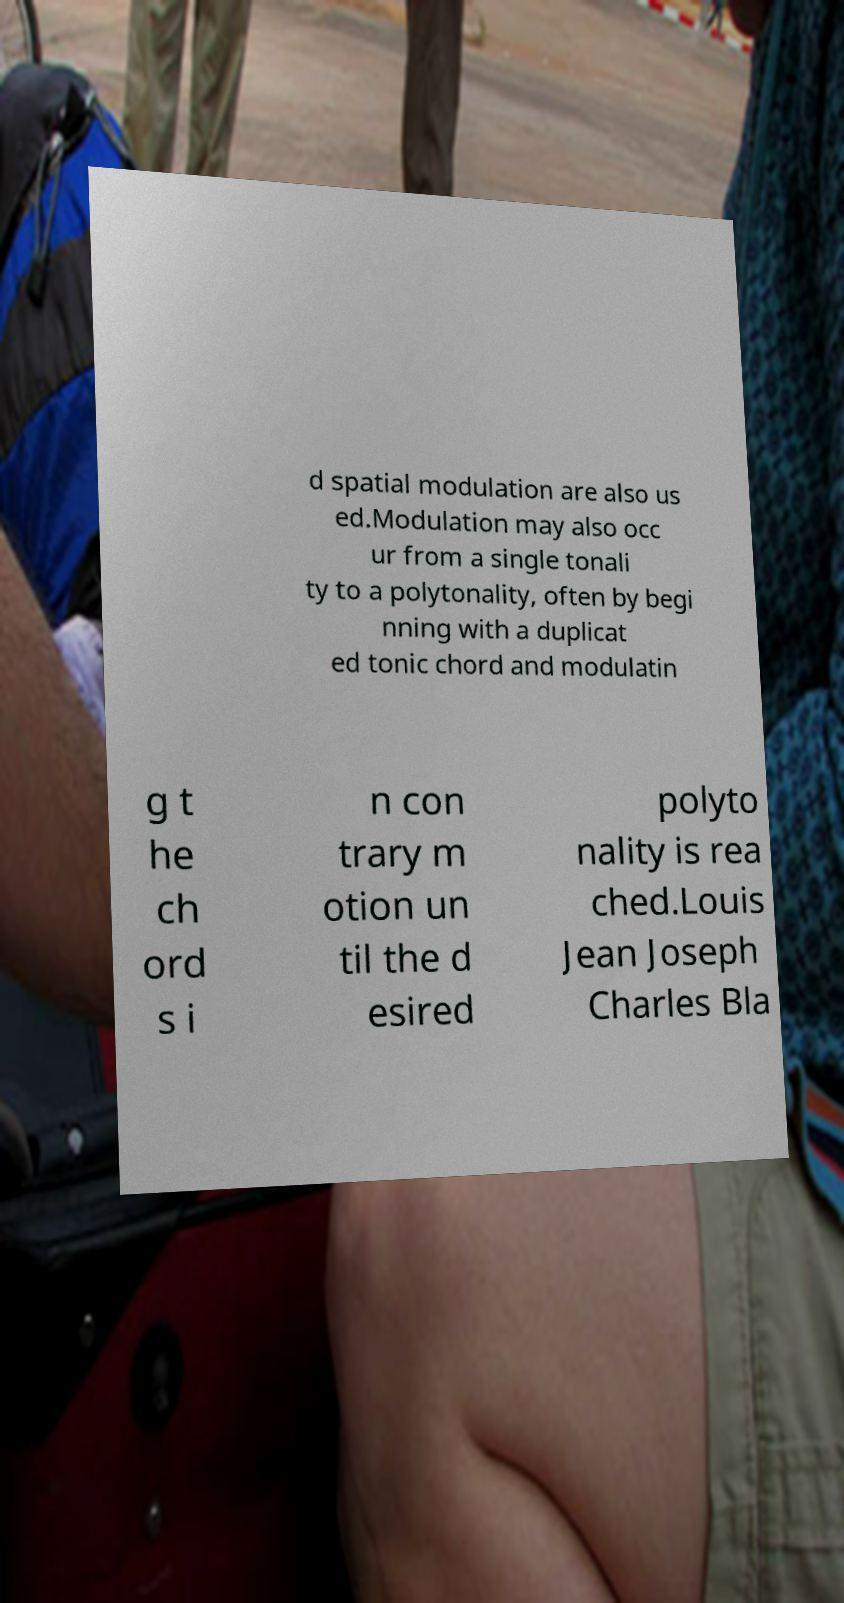Can you accurately transcribe the text from the provided image for me? d spatial modulation are also us ed.Modulation may also occ ur from a single tonali ty to a polytonality, often by begi nning with a duplicat ed tonic chord and modulatin g t he ch ord s i n con trary m otion un til the d esired polyto nality is rea ched.Louis Jean Joseph Charles Bla 